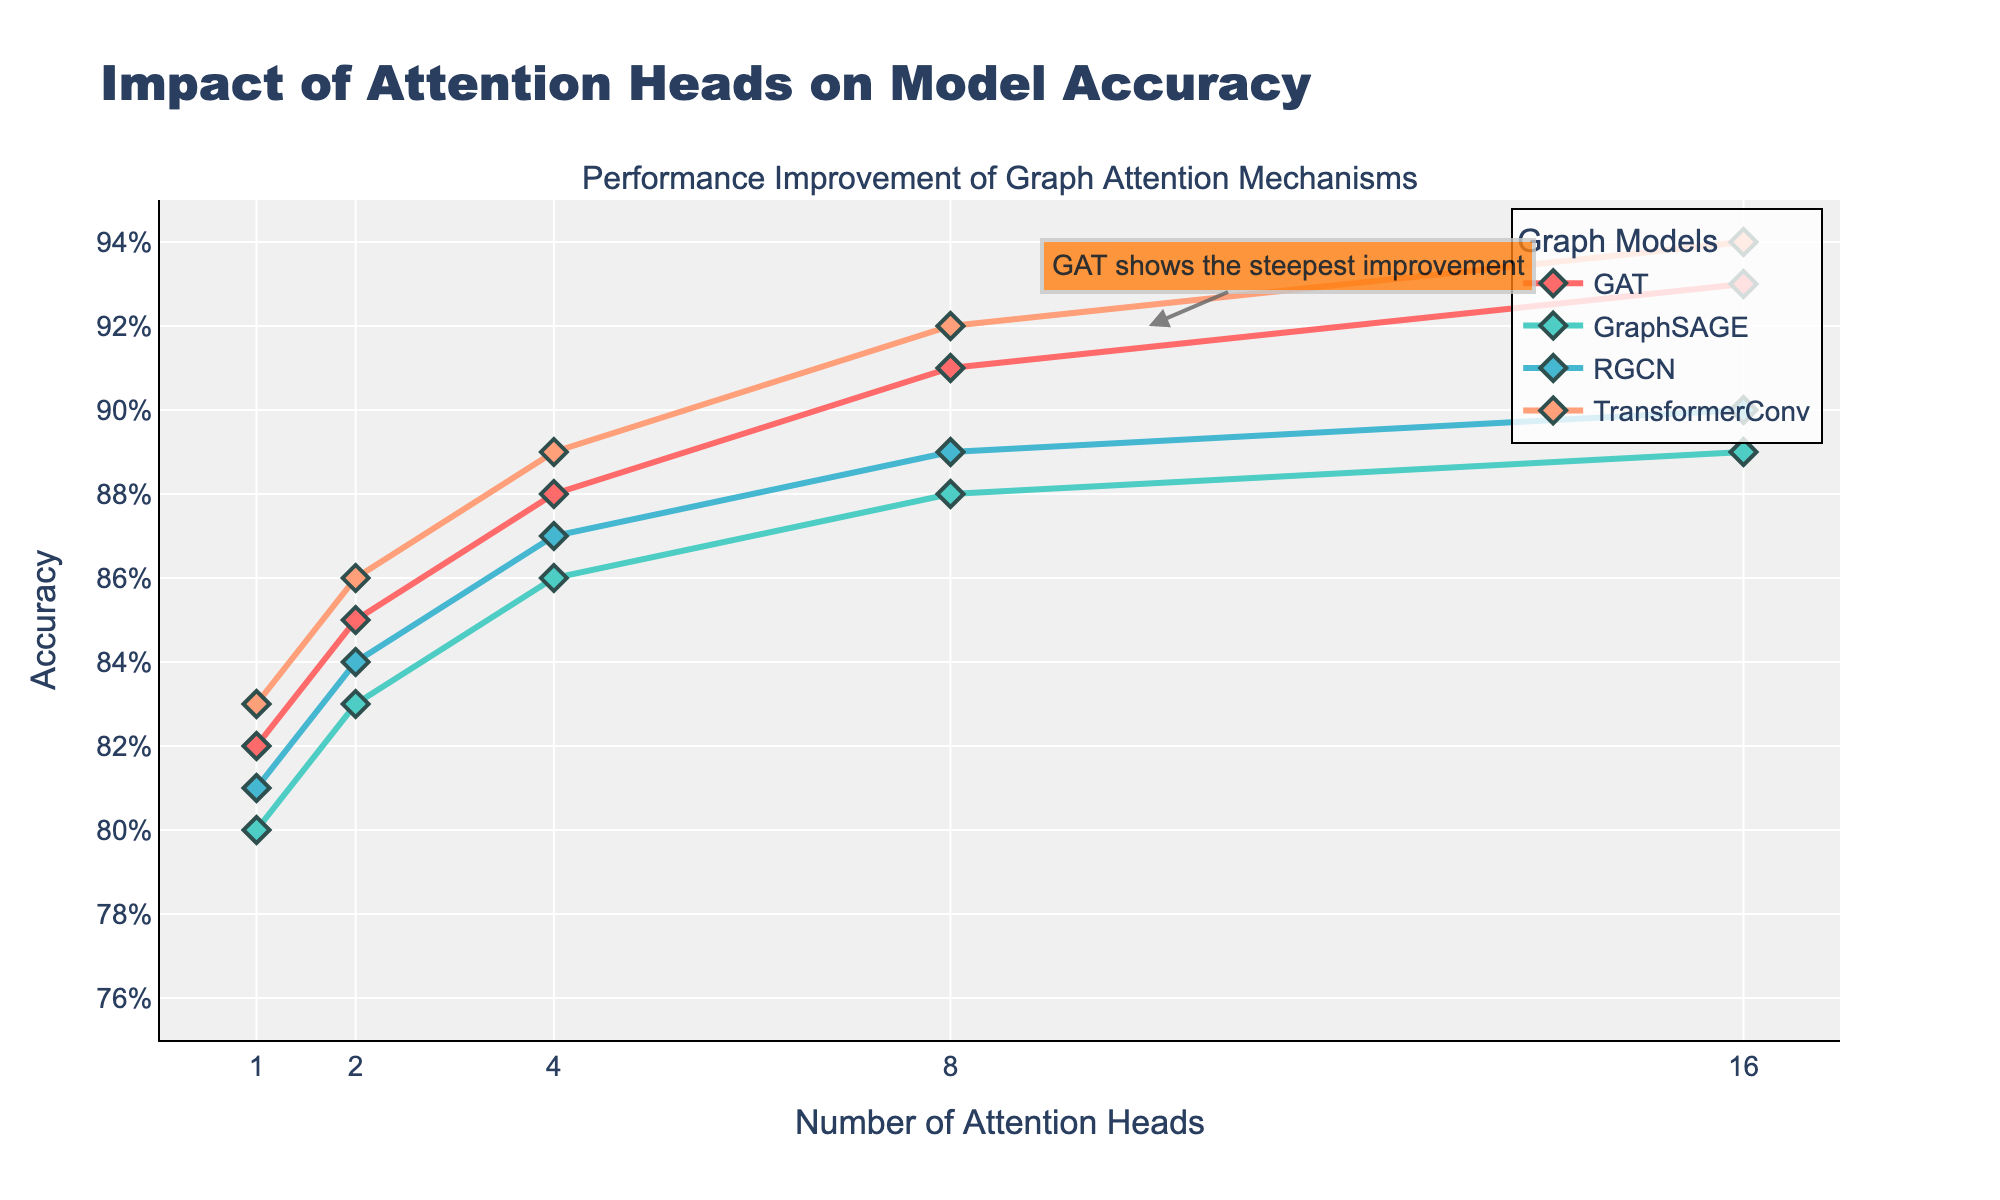What trend is observed for the GAT model as the number of attention heads increases? The GAT model shows a consistent increase in accuracy as the number of attention heads increases from 1 to 16. The accuracy starts at 0.82 with 1 head and reaches 0.93 with 16 heads.
Answer: Increasing trend Which model has the highest accuracy with 8 attention heads? By comparing the accuracy values for each model with 8 attention heads, TransformerConv shows the highest accuracy at 0.92.
Answer: TransformerConv What is the difference in accuracy between TransformerConv and GraphSAGE with 16 attention heads? TransformerConv has an accuracy of 0.94 with 16 attention heads, while GraphSAGE has an accuracy of 0.89. The difference is calculated as 0.94 - 0.89.
Answer: 0.05 How do the performances of GraphSAGE and RGCN compare at 4 attention heads? With 4 attention heads, GraphSAGE has an accuracy of 0.86, while RGCN has an accuracy of 0.87. RGCN performs slightly better than GraphSAGE by a margin of 0.01.
Answer: RGCN performs better Which model shows the steepest improvement when increasing the number of attention heads from 1 to 8? GAT shows the most significant improvement, increasing from 0.82 to 0.91. This conclusion is based on the annotation in the figure and observed values.
Answer: GAT If we sum the accuracies of all models with 1 attention head, what is the total value? The accuracies of models with 1 attention head are: GAT (0.82), GraphSAGE (0.80), RGCN (0.81), and TransformerConv (0.83). Summing these values: 0.82 + 0.80 + 0.81 + 0.83 = 3.26.
Answer: 3.26 What can be said about the trend of RGCN as the number of attention heads increases? The accuracy of RGCN increases consistently as the number of attention heads increases from 1 to 16, starting at 0.81 and reaching 0.90.
Answer: Increasing trend Which model has the lowest accuracy with 2 attention heads and what is that accuracy? GraphSAGE has the lowest accuracy with 2 attention heads, which is 0.83.
Answer: GraphSAGE, 0.83 Calculate the average accuracy for GAT across all the attention head settings presented. The accuracies for GAT are 0.82, 0.85, 0.88, 0.91, and 0.93. Summing these values: 0.82 + 0.85 + 0.88 + 0.91 + 0.93 = 4.39. Dividing by 5 (number of data points) gives the average: 4.39 / 5 = 0.878.
Answer: 0.878 